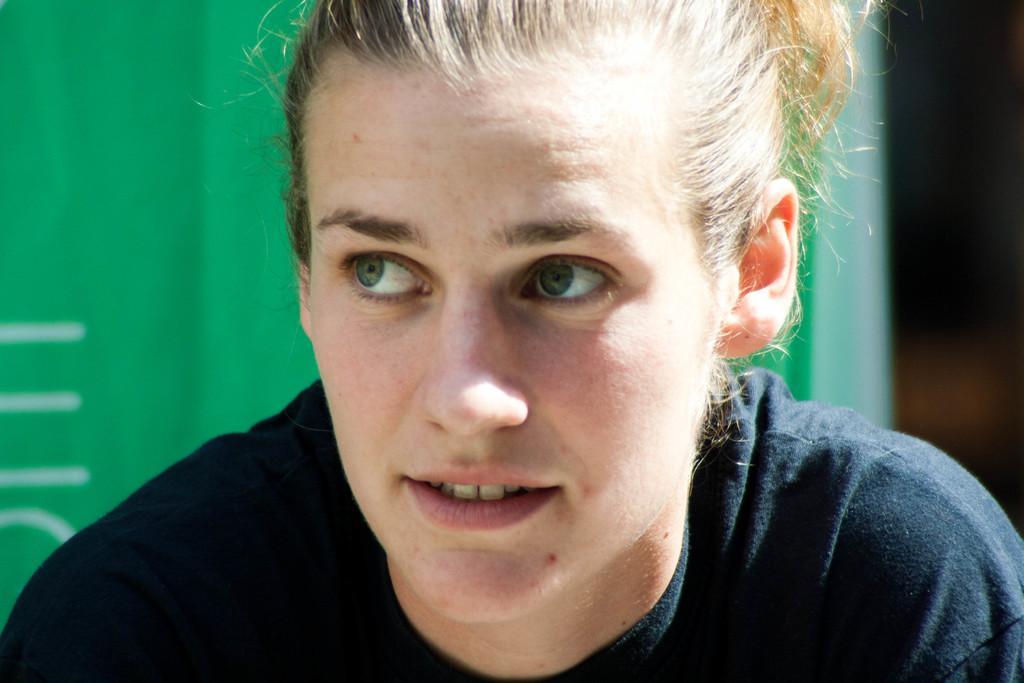Can you describe this image briefly? Here we can see a woman and there is a green color background. 